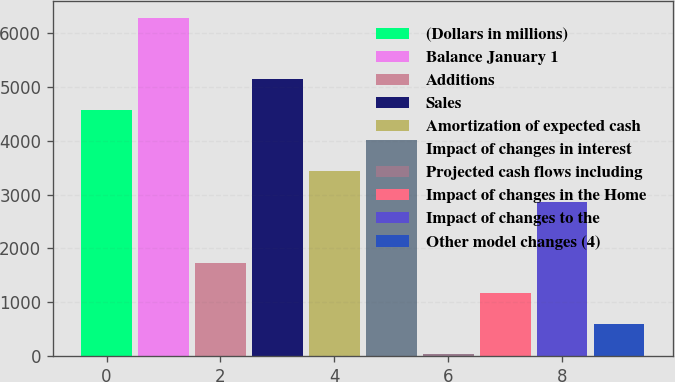Convert chart to OTSL. <chart><loc_0><loc_0><loc_500><loc_500><bar_chart><fcel>(Dollars in millions)<fcel>Balance January 1<fcel>Additions<fcel>Sales<fcel>Amortization of expected cash<fcel>Impact of changes in interest<fcel>Projected cash flows including<fcel>Impact of changes in the Home<fcel>Impact of changes to the<fcel>Other model changes (4)<nl><fcel>4578.2<fcel>6284.9<fcel>1733.7<fcel>5147.1<fcel>3440.4<fcel>4009.3<fcel>27<fcel>1164.8<fcel>2871.5<fcel>595.9<nl></chart> 